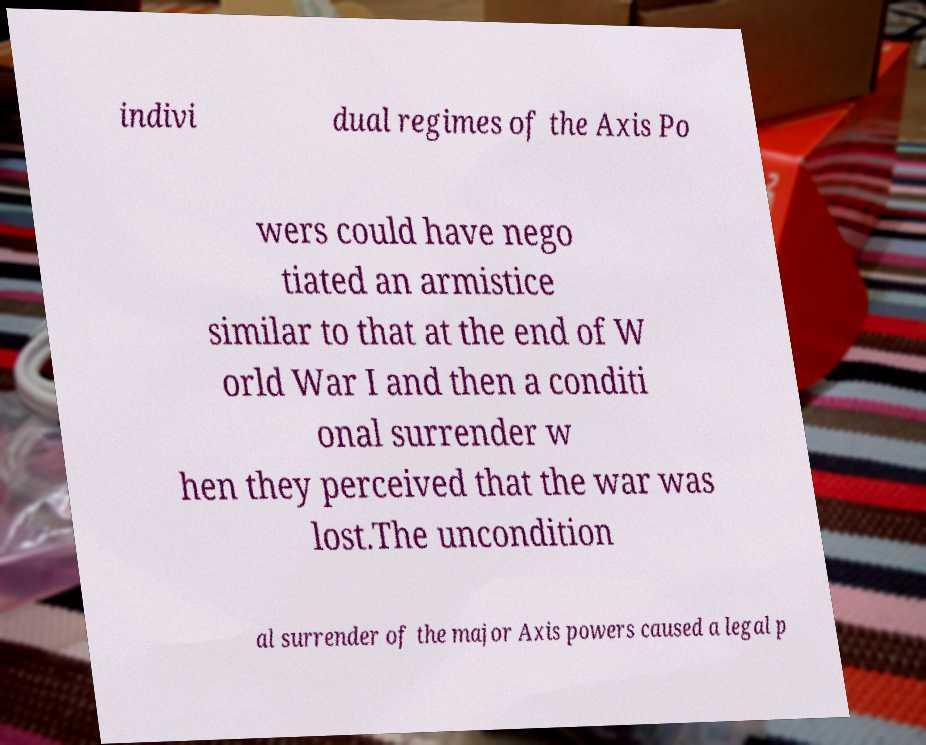Can you read and provide the text displayed in the image?This photo seems to have some interesting text. Can you extract and type it out for me? indivi dual regimes of the Axis Po wers could have nego tiated an armistice similar to that at the end of W orld War I and then a conditi onal surrender w hen they perceived that the war was lost.The uncondition al surrender of the major Axis powers caused a legal p 